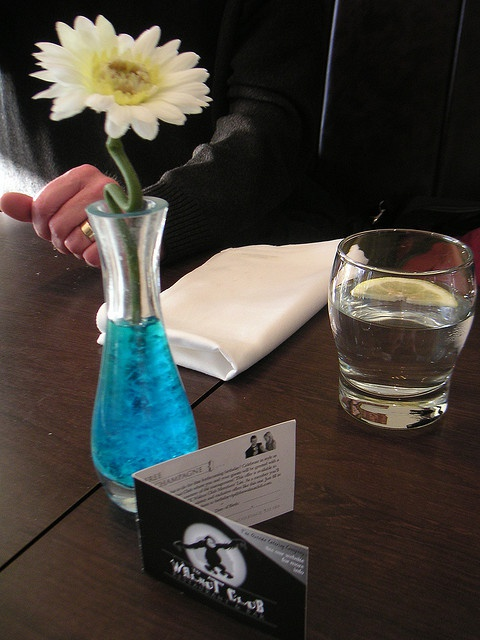Describe the objects in this image and their specific colors. I can see dining table in black and gray tones, people in black, brown, gray, and maroon tones, cup in black, gray, maroon, and tan tones, and vase in black, teal, darkgray, and lightgray tones in this image. 